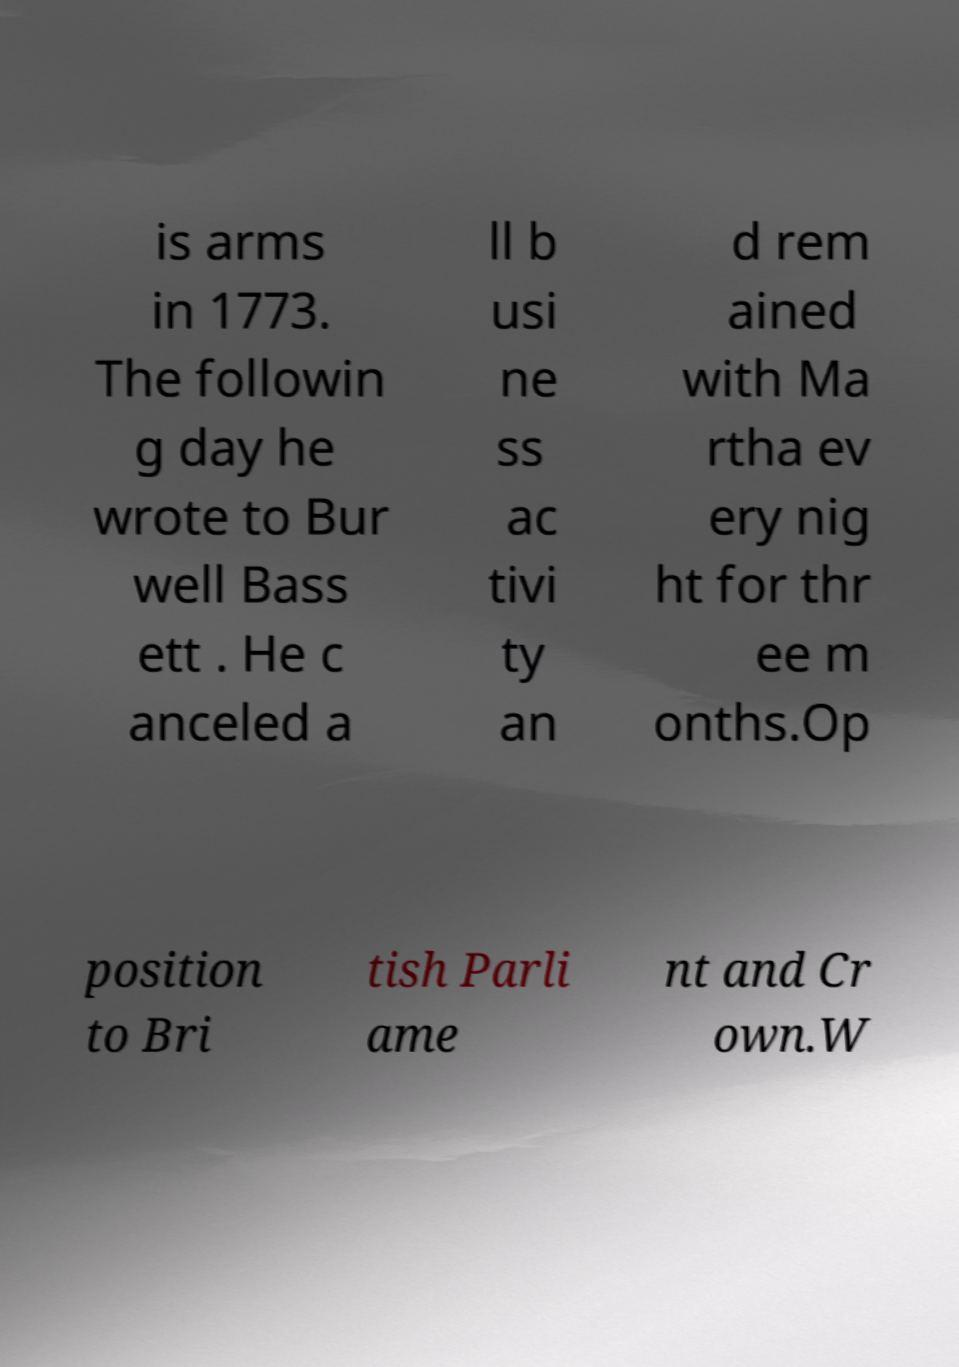For documentation purposes, I need the text within this image transcribed. Could you provide that? is arms in 1773. The followin g day he wrote to Bur well Bass ett . He c anceled a ll b usi ne ss ac tivi ty an d rem ained with Ma rtha ev ery nig ht for thr ee m onths.Op position to Bri tish Parli ame nt and Cr own.W 